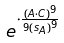<formula> <loc_0><loc_0><loc_500><loc_500>e ^ { \cdot \frac { ( A \cdot C ) ^ { 9 } } { 9 { ( s _ { A } ) } ^ { 9 } } }</formula> 